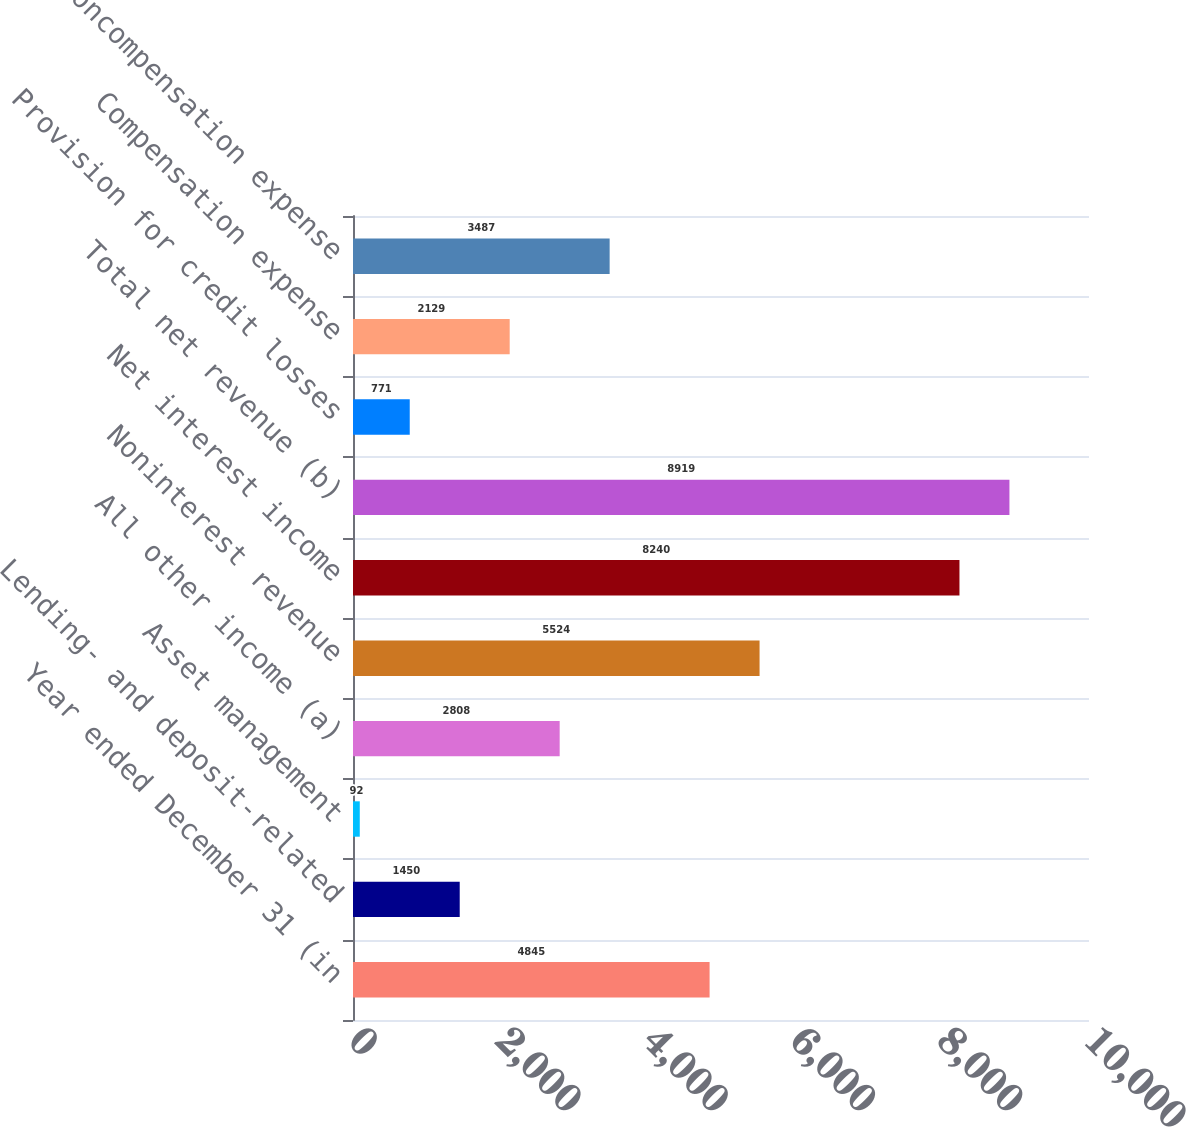<chart> <loc_0><loc_0><loc_500><loc_500><bar_chart><fcel>Year ended December 31 (in<fcel>Lending- and deposit-related<fcel>Asset management<fcel>All other income (a)<fcel>Noninterest revenue<fcel>Net interest income<fcel>Total net revenue (b)<fcel>Provision for credit losses<fcel>Compensation expense<fcel>Noncompensation expense<nl><fcel>4845<fcel>1450<fcel>92<fcel>2808<fcel>5524<fcel>8240<fcel>8919<fcel>771<fcel>2129<fcel>3487<nl></chart> 